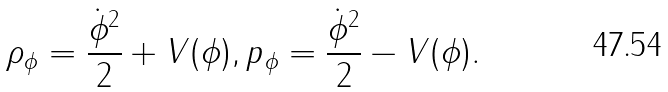Convert formula to latex. <formula><loc_0><loc_0><loc_500><loc_500>\rho _ { \phi } = \frac { \dot { \phi } ^ { 2 } } { 2 } + V ( \phi ) , p _ { \phi } = \frac { \dot { \phi } ^ { 2 } } { 2 } - V ( \phi ) .</formula> 